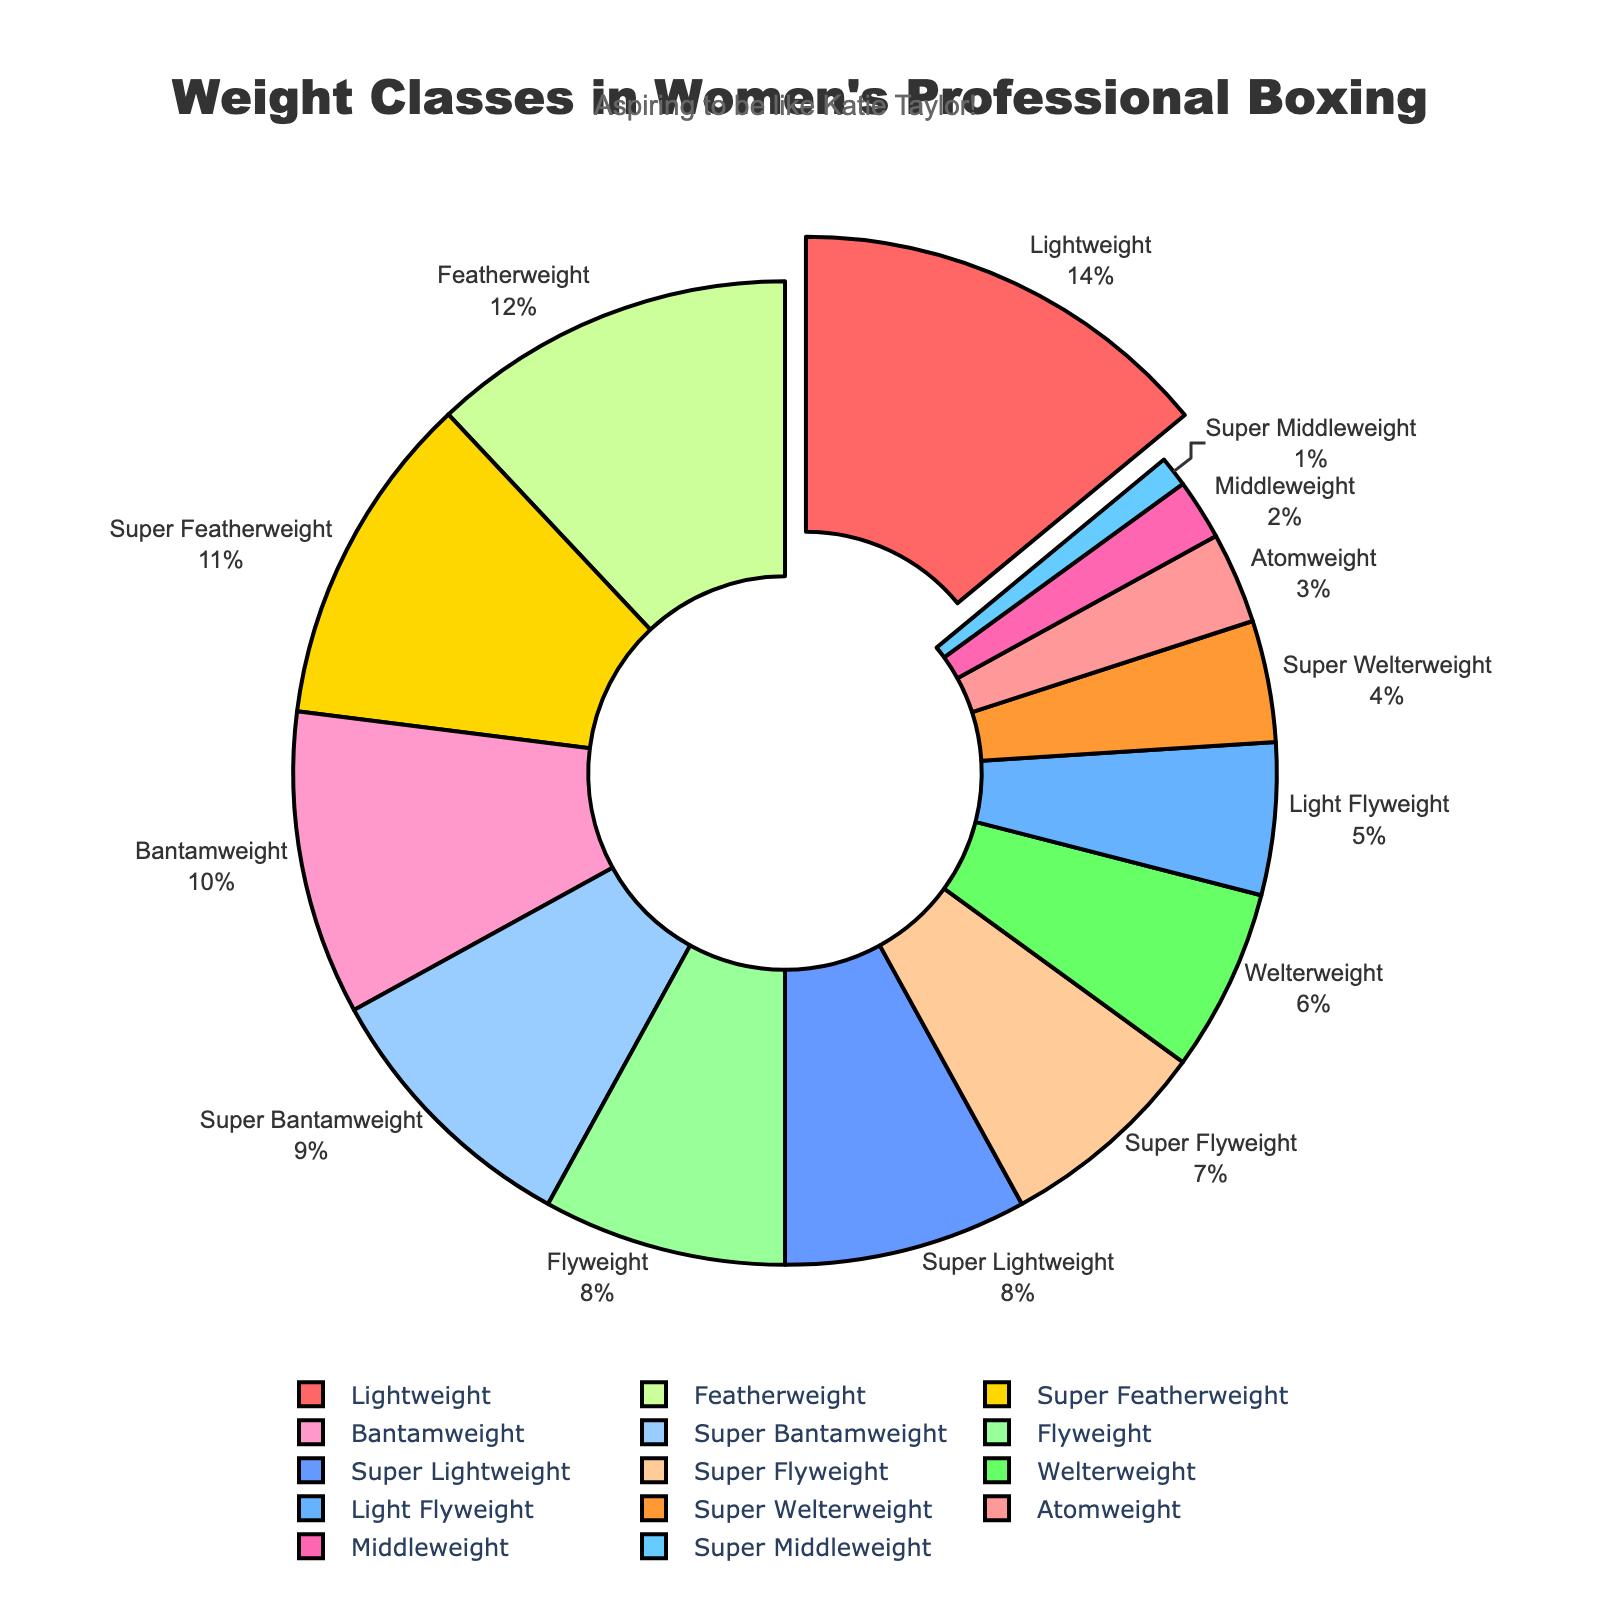Which weight class has the highest percentage? Look for the weight class with the largest slice in the pie chart. The pulled-out segment of the pie indicates the largest percentage.
Answer: Lightweight How much larger is the percentage of Lightweight compared to Flyweight? Lightweight has a percentage of 14%, and Flyweight has 8%. Subtract the Flyweight percentage from the Lightweight percentage: 14% - 8%.
Answer: 6% What is the total percentage of Featherweight, Super Featherweight, and Lightweight combined? Sum the percentages of Featherweight (12%), Super Featherweight (11%), and Lightweight (14%). 12% + 11% + 14%.
Answer: 37% Which weight class has a smaller percentage: Middleweight or Super Middleweight? Compare the percentages of Middleweight (2%) and Super Middleweight (1%).
Answer: Super Middleweight How does the percentage of Atomweight compare to the combined percentage of Super Lightweight and Welterweight? First, find the combined percentage of Super Lightweight (8%) and Welterweight (6%) which is 14%. Then compare it to Atomweight (3%).
Answer: Smaller by 11% What is the average percentage of Atomweight, Light Flyweight, and Flyweight? Sum the percentages of Atomweight (3%), Light Flyweight (5%), and Flyweight (8%), then divide by 3. (3% + 5% + 8%) / 3.
Answer: 5.33% Which color corresponds to the Bantamweight class? The colors follow a specific sequence; locate the Bantamweight segment in the chart and note its color. Bantamweight is the sixth segment, corresponding to a certain color.
Answer: Pink (around the sixth color in the sequence) Is the percentage for Featherweight greater than the combined percentage of Bantamweight and Super Bantamweight? Combine the percentages for Bantamweight (10%) and Super Bantamweight (9%) making 19%, then compare it to Featherweight (12%).
Answer: No What is the difference in percentage between the two highest weight classes (Lightweight and Featherweight)? The two highest percentages are Lightweight (14%) and Featherweight (12%). Subtract Featherweight from Lightweight: 14% - 12%.
Answer: 2% What is the median percentage value of all weight classes shown in the chart? List all percentages: 1, 2, 3, 4, 5, 6, 7, 8, 8, 9, 10, 11, 12, 14. The median is the middle value when sorted: 8%.
Answer: 8% 